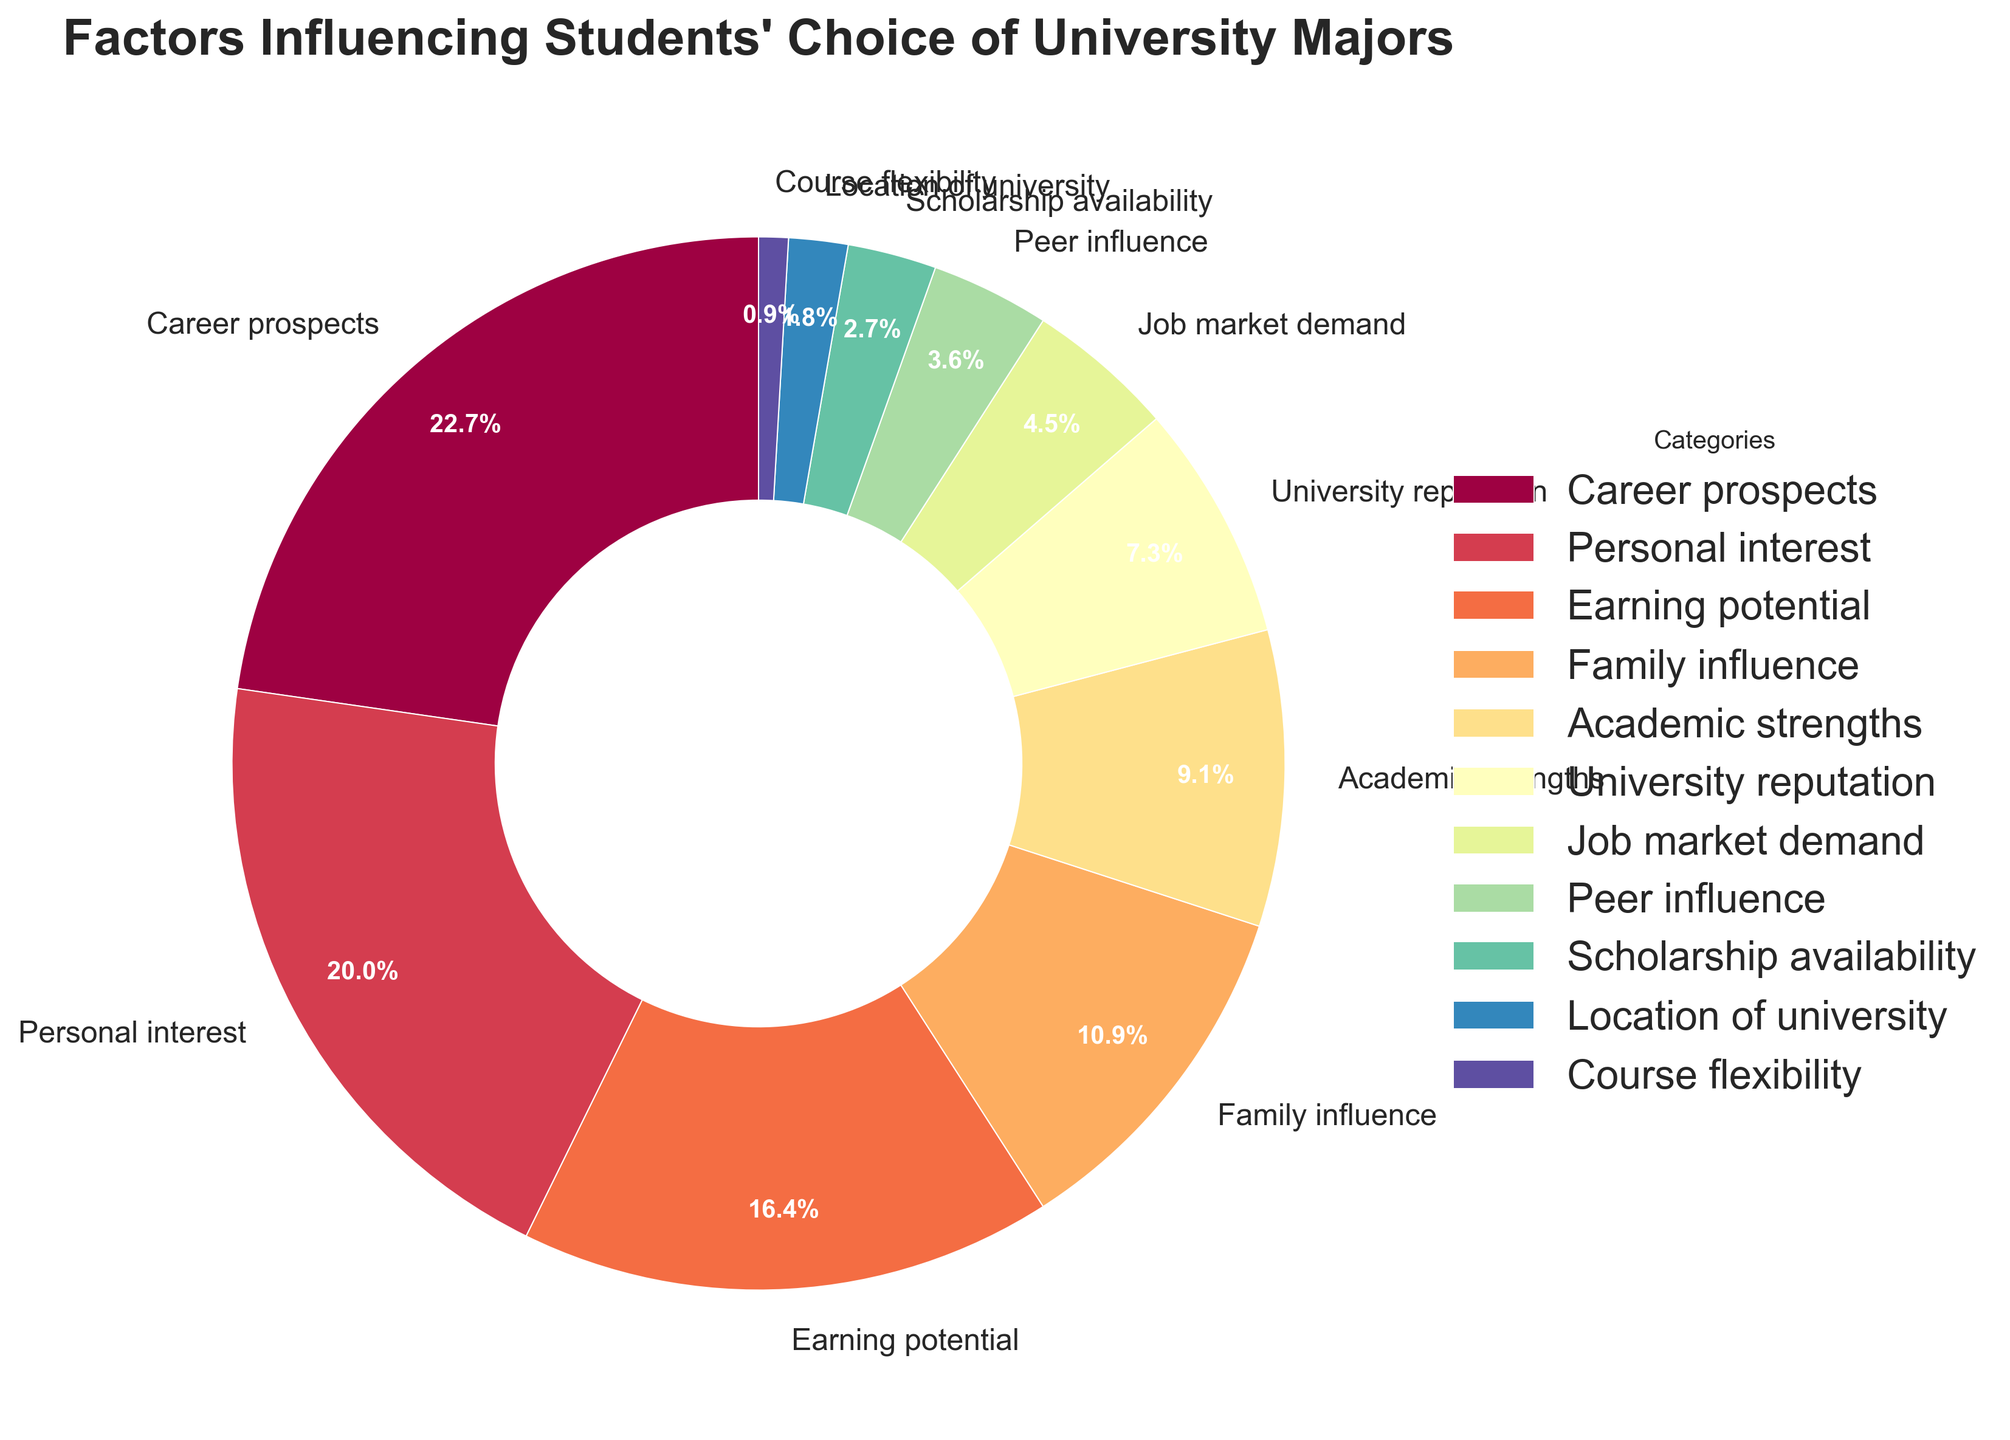What is the most influential factor in students' choice of university majors according to the pie chart? The pie chart shows that "Career prospects" is the slice with the highest percentage at 25%, making it the most influential factor.
Answer: Career prospects Which factor has a larger influence: Family influence or Peer influence, and by how much? "Family influence" has a percentage of 12%, and "Peer influence" has 4%. The difference between these two percentages is 12% - 4% = 8%.
Answer: Family influence by 8% What is the combined percentage of students influenced by Earning potential and University reputation? The slice for "Earning potential" is 18% and for "University reputation" is 8%. Adding these gives 18% + 8% = 26%.
Answer: 26% How does the influence of Personal interest compare to Academic strengths? The percentage for "Personal interest" is 22% while "Academic strengths" is 10%. Since 22% is more than 10%, "Personal interest" has a greater influence.
Answer: Personal interest is greater than Academic strengths Which factor has the smallest influence on students' choice of university majors? The pie chart shows "Course flexibility" with the smallest slice at 1%.
Answer: Course flexibility What is the percentage difference between Career prospects and Job market demand? "Career prospects" has 25% and "Job market demand" has 5%. The percentage difference is 25% - 5% = 20%.
Answer: 20% Which three factors combined make up more than half of the total influence on students' choice? "Career prospects" (25%), "Personal interest" (22%), and "Earning potential" (18%) together sum up to 25% + 22% + 18% = 65%, which is more than half of the total 100%.
Answer: Career prospects, Personal interest, Earning potential What percent of students are influenced by either Family influence or Peer influence? "Family influence" is 12% and "Peer influence" is 4%. Adding them gives 12% + 4% = 16%.
Answer: 16% On average, what is the influence percentage of factors with less than 10%? Sums of percentages below 10%: "Academic strengths" (10%), "University reputation" (8%), "Job market demand" (5%), "Peer influence" (4%), "Scholarship availability" (3%), "Location of university" (2%), "Course flexibility" (1%). Sum: 10% + 8% + 5% + 4% + 3% + 2% + 1% = 33%. Number of factors: 7. The average is 33% / 7 ≈ 4.71%.
Answer: 4.71% What visual element helps us easily identify that Career prospects is the most influential factor? The "Career prospects" section of the pie chart has the largest slice, making it visually dominant and easy to identify as the most influential factor.
Answer: Largest slice 